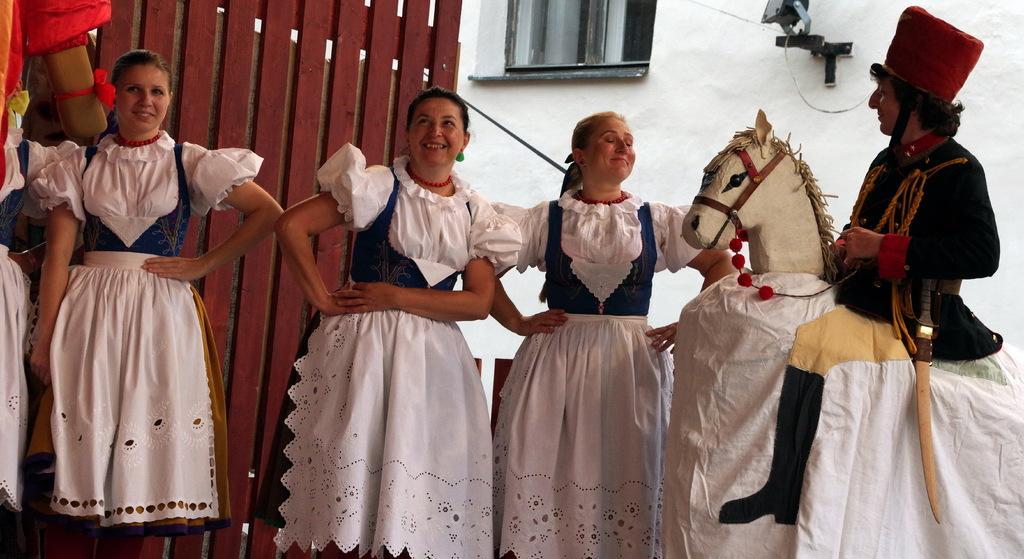Please provide a concise description of this image. In this picture there are people, among them there's a man wore costume and carrying a sword. In the background of the image we can see wooden planks, object on the wall and window. 